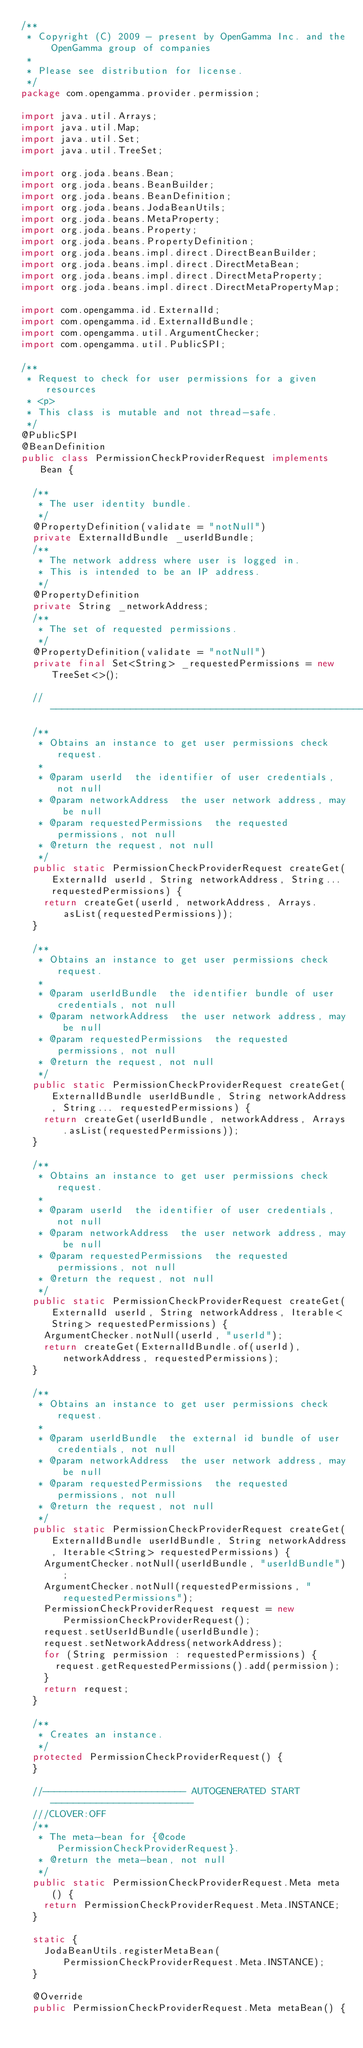<code> <loc_0><loc_0><loc_500><loc_500><_Java_>/**
 * Copyright (C) 2009 - present by OpenGamma Inc. and the OpenGamma group of companies
 *
 * Please see distribution for license.
 */
package com.opengamma.provider.permission;

import java.util.Arrays;
import java.util.Map;
import java.util.Set;
import java.util.TreeSet;

import org.joda.beans.Bean;
import org.joda.beans.BeanBuilder;
import org.joda.beans.BeanDefinition;
import org.joda.beans.JodaBeanUtils;
import org.joda.beans.MetaProperty;
import org.joda.beans.Property;
import org.joda.beans.PropertyDefinition;
import org.joda.beans.impl.direct.DirectBeanBuilder;
import org.joda.beans.impl.direct.DirectMetaBean;
import org.joda.beans.impl.direct.DirectMetaProperty;
import org.joda.beans.impl.direct.DirectMetaPropertyMap;

import com.opengamma.id.ExternalId;
import com.opengamma.id.ExternalIdBundle;
import com.opengamma.util.ArgumentChecker;
import com.opengamma.util.PublicSPI;

/**
 * Request to check for user permissions for a given resources
 * <p>
 * This class is mutable and not thread-safe.
 */
@PublicSPI
@BeanDefinition
public class PermissionCheckProviderRequest implements Bean {

  /**
   * The user identity bundle.
   */
  @PropertyDefinition(validate = "notNull")
  private ExternalIdBundle _userIdBundle;
  /**
   * The network address where user is logged in.
   * This is intended to be an IP address.
   */
  @PropertyDefinition
  private String _networkAddress;
  /**
   * The set of requested permissions.
   */
  @PropertyDefinition(validate = "notNull")
  private final Set<String> _requestedPermissions = new TreeSet<>();

  //-------------------------------------------------------------------------
  /**
   * Obtains an instance to get user permissions check request.
   * 
   * @param userId  the identifier of user credentials, not null
   * @param networkAddress  the user network address, may be null
   * @param requestedPermissions  the requested permissions, not null
   * @return the request, not null
   */
  public static PermissionCheckProviderRequest createGet(ExternalId userId, String networkAddress, String... requestedPermissions) {
    return createGet(userId, networkAddress, Arrays.asList(requestedPermissions));
  }

  /**
   * Obtains an instance to get user permissions check request.
   * 
   * @param userIdBundle  the identifier bundle of user credentials, not null
   * @param networkAddress  the user network address, may be null
   * @param requestedPermissions  the requested permissions, not null
   * @return the request, not null
   */
  public static PermissionCheckProviderRequest createGet(ExternalIdBundle userIdBundle, String networkAddress, String... requestedPermissions) {
    return createGet(userIdBundle, networkAddress, Arrays.asList(requestedPermissions));
  }

  /**
   * Obtains an instance to get user permissions check request.
   * 
   * @param userId  the identifier of user credentials, not null
   * @param networkAddress  the user network address, may be null
   * @param requestedPermissions  the requested permissions, not null
   * @return the request, not null
   */
  public static PermissionCheckProviderRequest createGet(ExternalId userId, String networkAddress, Iterable<String> requestedPermissions) {
    ArgumentChecker.notNull(userId, "userId");
    return createGet(ExternalIdBundle.of(userId), networkAddress, requestedPermissions);
  }

  /**
   * Obtains an instance to get user permissions check request.
   * 
   * @param userIdBundle  the external id bundle of user credentials, not null
   * @param networkAddress  the user network address, may be null
   * @param requestedPermissions  the requested permissions, not null
   * @return the request, not null
   */
  public static PermissionCheckProviderRequest createGet(ExternalIdBundle userIdBundle, String networkAddress, Iterable<String> requestedPermissions) {
    ArgumentChecker.notNull(userIdBundle, "userIdBundle");
    ArgumentChecker.notNull(requestedPermissions, "requestedPermissions");
    PermissionCheckProviderRequest request = new PermissionCheckProviderRequest();
    request.setUserIdBundle(userIdBundle);
    request.setNetworkAddress(networkAddress);
    for (String permission : requestedPermissions) {
      request.getRequestedPermissions().add(permission);
    }
    return request;
  }

  /**
   * Creates an instance.
   */
  protected PermissionCheckProviderRequest() {
  }

  //------------------------- AUTOGENERATED START -------------------------
  ///CLOVER:OFF
  /**
   * The meta-bean for {@code PermissionCheckProviderRequest}.
   * @return the meta-bean, not null
   */
  public static PermissionCheckProviderRequest.Meta meta() {
    return PermissionCheckProviderRequest.Meta.INSTANCE;
  }

  static {
    JodaBeanUtils.registerMetaBean(PermissionCheckProviderRequest.Meta.INSTANCE);
  }

  @Override
  public PermissionCheckProviderRequest.Meta metaBean() {</code> 